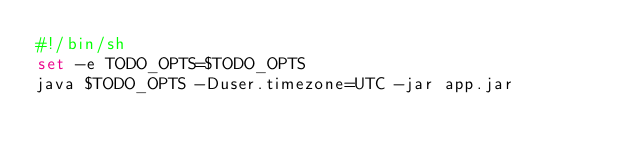<code> <loc_0><loc_0><loc_500><loc_500><_Bash_>#!/bin/sh
set -e TODO_OPTS=$TODO_OPTS
java $TODO_OPTS -Duser.timezone=UTC -jar app.jar</code> 